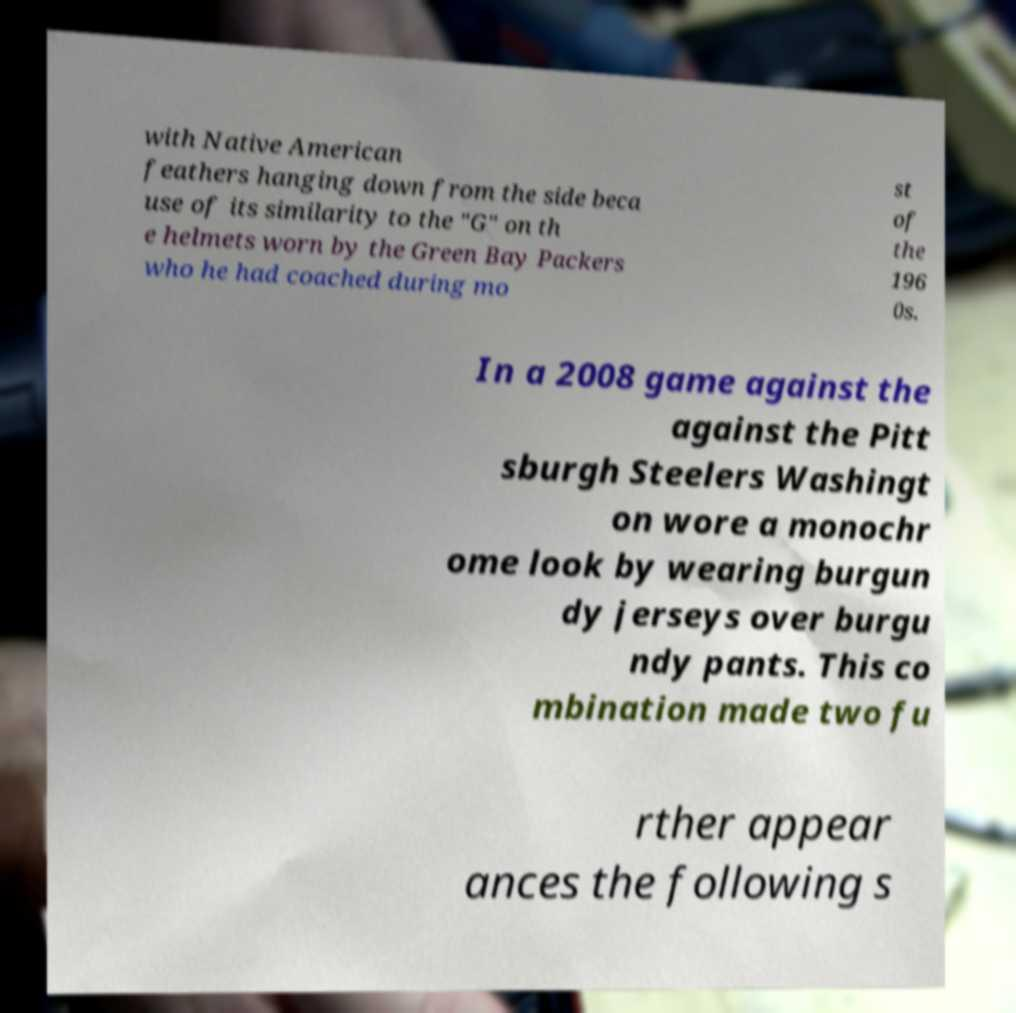Can you read and provide the text displayed in the image?This photo seems to have some interesting text. Can you extract and type it out for me? with Native American feathers hanging down from the side beca use of its similarity to the "G" on th e helmets worn by the Green Bay Packers who he had coached during mo st of the 196 0s. In a 2008 game against the against the Pitt sburgh Steelers Washingt on wore a monochr ome look by wearing burgun dy jerseys over burgu ndy pants. This co mbination made two fu rther appear ances the following s 